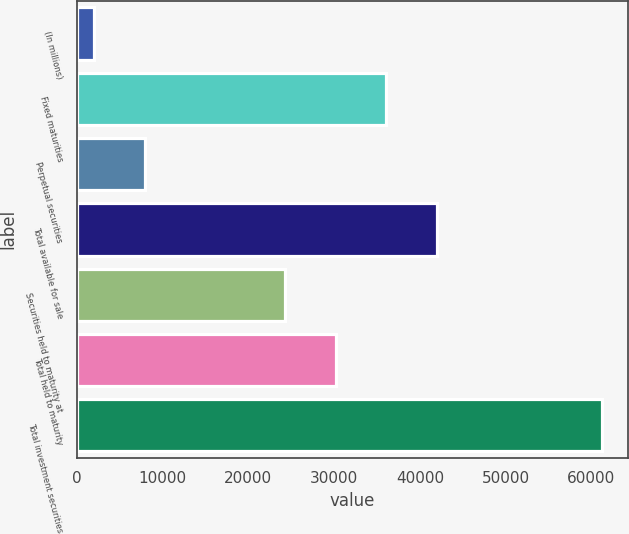Convert chart. <chart><loc_0><loc_0><loc_500><loc_500><bar_chart><fcel>(In millions)<fcel>Fixed maturities<fcel>Perpetual securities<fcel>Total available for sale<fcel>Securities held to maturity at<fcel>Total held to maturity<fcel>Total investment securities<nl><fcel>2008<fcel>36083.6<fcel>7931.8<fcel>42007.4<fcel>24236<fcel>30159.8<fcel>61246<nl></chart> 